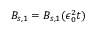Convert formula to latex. <formula><loc_0><loc_0><loc_500><loc_500>B _ { s , 1 } = B _ { s , 1 } ( \epsilon _ { 0 } ^ { 2 } t )</formula> 